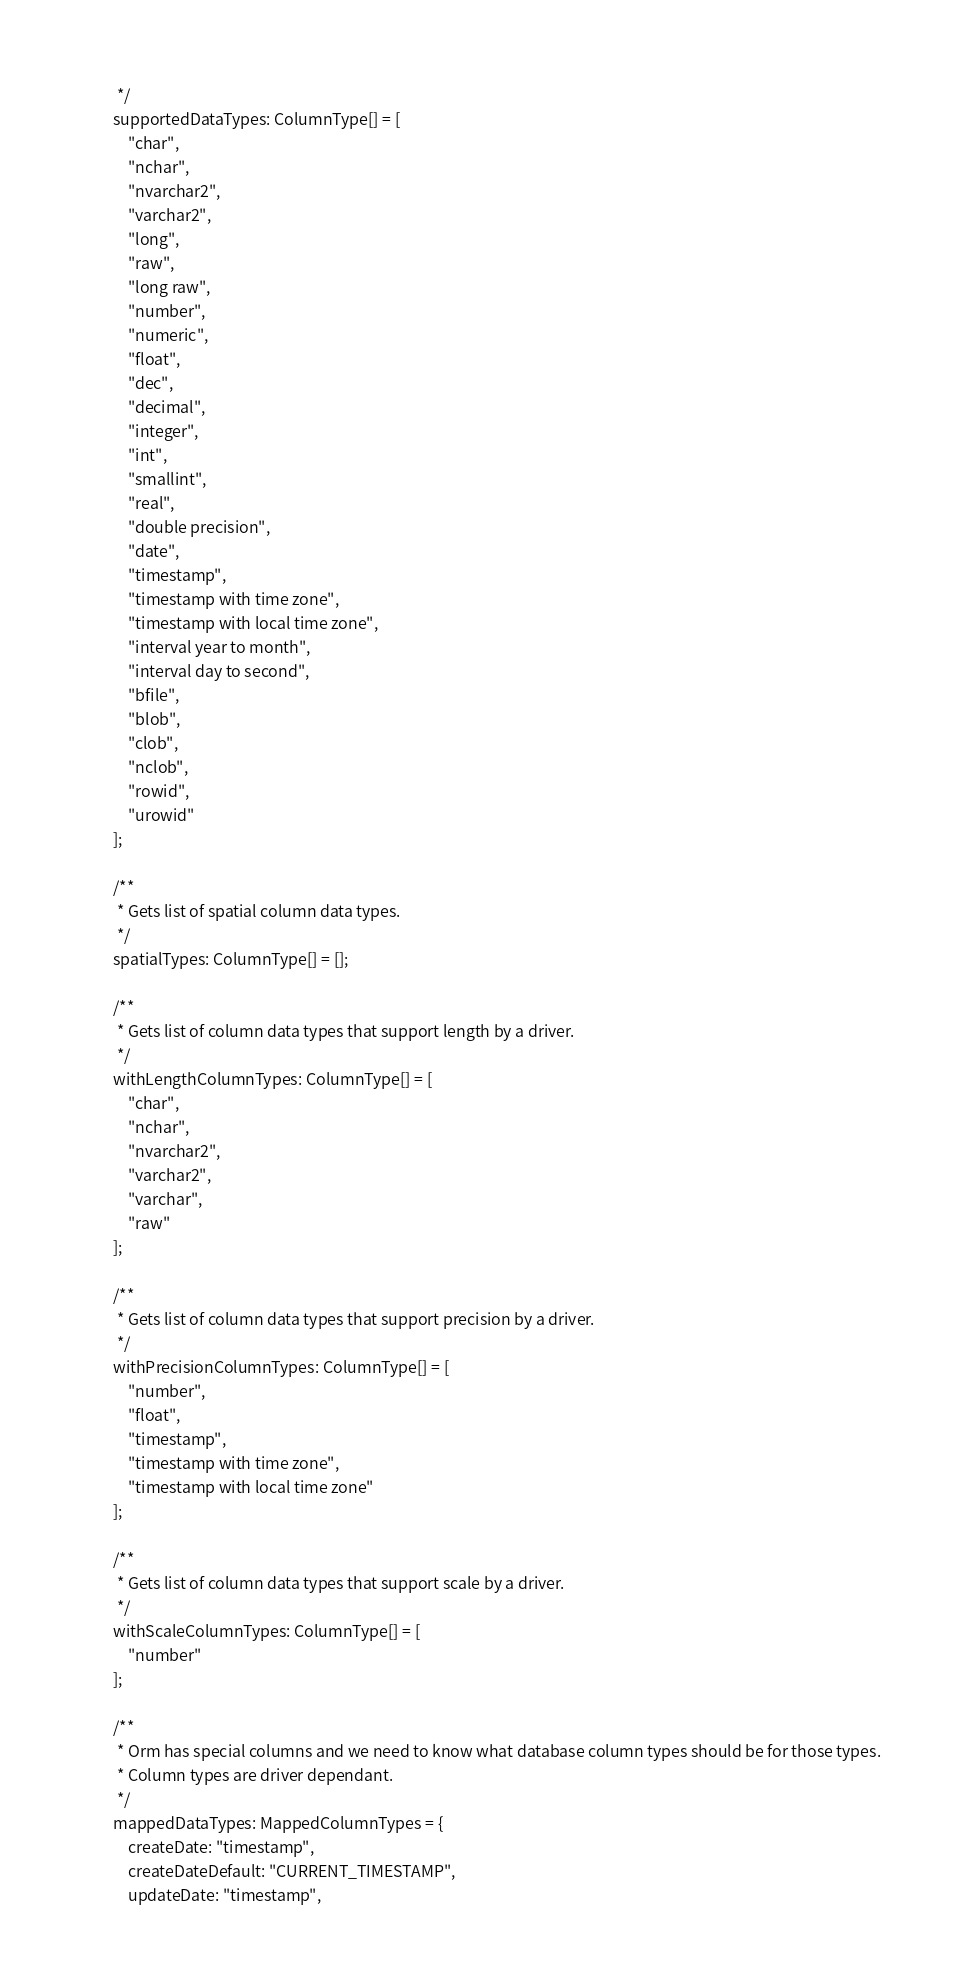Convert code to text. <code><loc_0><loc_0><loc_500><loc_500><_TypeScript_>     */
    supportedDataTypes: ColumnType[] = [
        "char",
        "nchar",
        "nvarchar2",
        "varchar2",
        "long",
        "raw",
        "long raw",
        "number",
        "numeric",
        "float",
        "dec",
        "decimal",
        "integer",
        "int",
        "smallint",
        "real",
        "double precision",
        "date",
        "timestamp",
        "timestamp with time zone",
        "timestamp with local time zone",
        "interval year to month",
        "interval day to second",
        "bfile",
        "blob",
        "clob",
        "nclob",
        "rowid",
        "urowid"
    ];

    /**
     * Gets list of spatial column data types.
     */
    spatialTypes: ColumnType[] = [];

    /**
     * Gets list of column data types that support length by a driver.
     */
    withLengthColumnTypes: ColumnType[] = [
        "char",
        "nchar",
        "nvarchar2",
        "varchar2",
        "varchar",
        "raw"
    ];

    /**
     * Gets list of column data types that support precision by a driver.
     */
    withPrecisionColumnTypes: ColumnType[] = [
        "number",
        "float",
        "timestamp",
        "timestamp with time zone",
        "timestamp with local time zone"
    ];

    /**
     * Gets list of column data types that support scale by a driver.
     */
    withScaleColumnTypes: ColumnType[] = [
        "number"
    ];

    /**
     * Orm has special columns and we need to know what database column types should be for those types.
     * Column types are driver dependant.
     */
    mappedDataTypes: MappedColumnTypes = {
        createDate: "timestamp",
        createDateDefault: "CURRENT_TIMESTAMP",
        updateDate: "timestamp",</code> 